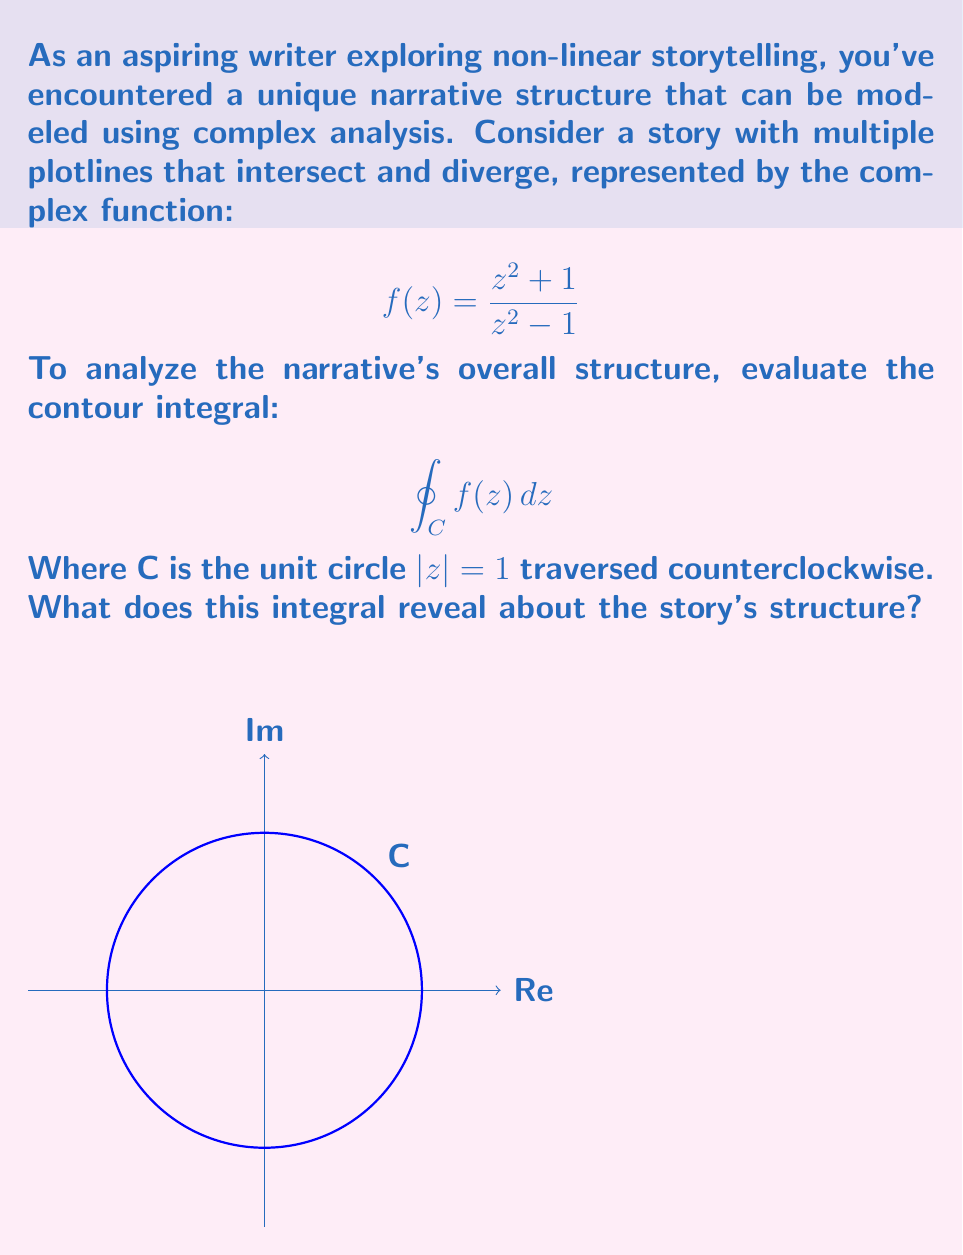Solve this math problem. To evaluate this contour integral, we'll use the Residue Theorem. The steps are as follows:

1) First, identify the poles of $f(z)$ inside the unit circle. The denominator $z^2 - 1 = (z+1)(z-1)$ gives us poles at $z = \pm 1$, but only $z = 1$ is inside the unit circle.

2) Calculate the residue at $z = 1$:
   $$\text{Res}(f, 1) = \lim_{z \to 1} (z-1) \cdot \frac{z^2 + 1}{z^2 - 1}$$
   $$= \lim_{z \to 1} \frac{z^2 + 1}{z+1} = \frac{1^2 + 1}{1+1} = 1$$

3) Apply the Residue Theorem:
   $$\oint_C f(z) dz = 2\pi i \cdot \text{Res}(f, 1) = 2\pi i$$

4) Interpretation for storytelling:
   - The non-zero result indicates that the story has a central theme or plot point (represented by the pole at z = 1) that all storylines revolve around.
   - The magnitude $2\pi$ suggests a complete cycle or revolution, implying that the narrative comes full circle despite its non-linear structure.
   - The imaginary unit $i$ could represent the complexity or unconventional nature of the storytelling approach.

This mathematical model reveals a story with multiple intertwining plotlines that ultimately converge on a central theme, creating a cohesive narrative despite its non-linear presentation.
Answer: $2\pi i$ 